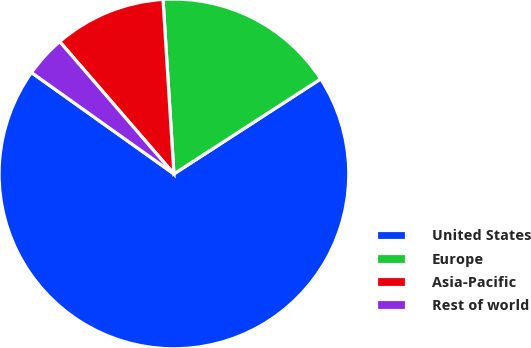Convert chart. <chart><loc_0><loc_0><loc_500><loc_500><pie_chart><fcel>United States<fcel>Europe<fcel>Asia-Pacific<fcel>Rest of world<nl><fcel>68.98%<fcel>16.85%<fcel>10.34%<fcel>3.82%<nl></chart> 